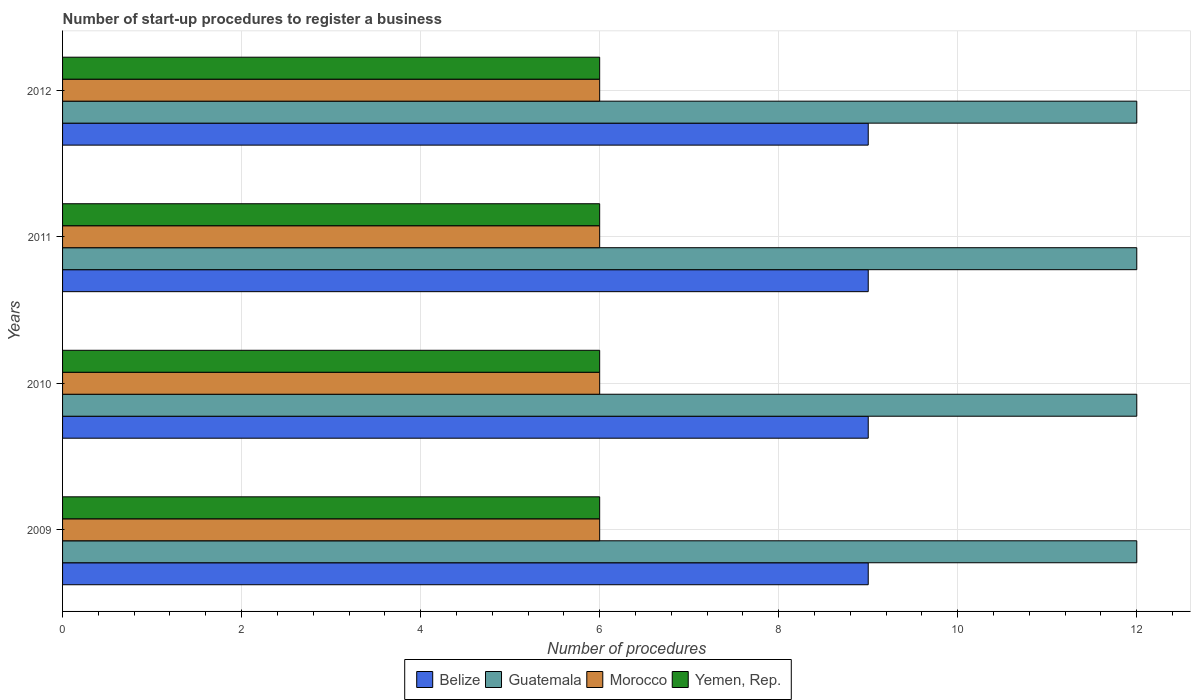How many groups of bars are there?
Offer a very short reply. 4. How many bars are there on the 2nd tick from the top?
Give a very brief answer. 4. How many bars are there on the 3rd tick from the bottom?
Offer a terse response. 4. What is the number of procedures required to register a business in Guatemala in 2011?
Provide a succinct answer. 12. Across all years, what is the maximum number of procedures required to register a business in Guatemala?
Ensure brevity in your answer.  12. In which year was the number of procedures required to register a business in Belize maximum?
Your response must be concise. 2009. What is the total number of procedures required to register a business in Guatemala in the graph?
Your answer should be very brief. 48. What is the difference between the number of procedures required to register a business in Belize in 2010 and that in 2011?
Provide a short and direct response. 0. In the year 2009, what is the difference between the number of procedures required to register a business in Morocco and number of procedures required to register a business in Guatemala?
Offer a terse response. -6. Is the difference between the number of procedures required to register a business in Morocco in 2010 and 2011 greater than the difference between the number of procedures required to register a business in Guatemala in 2010 and 2011?
Your answer should be compact. No. In how many years, is the number of procedures required to register a business in Guatemala greater than the average number of procedures required to register a business in Guatemala taken over all years?
Make the answer very short. 0. Is it the case that in every year, the sum of the number of procedures required to register a business in Morocco and number of procedures required to register a business in Guatemala is greater than the sum of number of procedures required to register a business in Belize and number of procedures required to register a business in Yemen, Rep.?
Make the answer very short. No. What does the 2nd bar from the top in 2012 represents?
Provide a short and direct response. Morocco. What does the 3rd bar from the bottom in 2012 represents?
Provide a short and direct response. Morocco. How many bars are there?
Offer a very short reply. 16. Are all the bars in the graph horizontal?
Ensure brevity in your answer.  Yes. How many years are there in the graph?
Your answer should be compact. 4. What is the difference between two consecutive major ticks on the X-axis?
Your response must be concise. 2. Where does the legend appear in the graph?
Provide a succinct answer. Bottom center. How are the legend labels stacked?
Keep it short and to the point. Horizontal. What is the title of the graph?
Your answer should be very brief. Number of start-up procedures to register a business. What is the label or title of the X-axis?
Your answer should be compact. Number of procedures. What is the Number of procedures in Guatemala in 2009?
Offer a very short reply. 12. What is the Number of procedures in Yemen, Rep. in 2009?
Provide a succinct answer. 6. What is the Number of procedures of Belize in 2010?
Your answer should be compact. 9. What is the Number of procedures in Morocco in 2010?
Provide a succinct answer. 6. What is the Number of procedures in Yemen, Rep. in 2010?
Provide a short and direct response. 6. What is the Number of procedures of Guatemala in 2011?
Make the answer very short. 12. What is the Number of procedures in Morocco in 2012?
Make the answer very short. 6. What is the Number of procedures in Yemen, Rep. in 2012?
Keep it short and to the point. 6. Across all years, what is the maximum Number of procedures in Guatemala?
Give a very brief answer. 12. Across all years, what is the maximum Number of procedures in Yemen, Rep.?
Provide a succinct answer. 6. Across all years, what is the minimum Number of procedures of Belize?
Keep it short and to the point. 9. Across all years, what is the minimum Number of procedures in Morocco?
Your answer should be very brief. 6. What is the difference between the Number of procedures in Morocco in 2009 and that in 2010?
Offer a very short reply. 0. What is the difference between the Number of procedures in Yemen, Rep. in 2009 and that in 2010?
Offer a very short reply. 0. What is the difference between the Number of procedures of Belize in 2009 and that in 2011?
Offer a very short reply. 0. What is the difference between the Number of procedures of Guatemala in 2009 and that in 2011?
Make the answer very short. 0. What is the difference between the Number of procedures of Morocco in 2009 and that in 2011?
Ensure brevity in your answer.  0. What is the difference between the Number of procedures of Yemen, Rep. in 2009 and that in 2011?
Keep it short and to the point. 0. What is the difference between the Number of procedures in Belize in 2009 and that in 2012?
Your answer should be compact. 0. What is the difference between the Number of procedures of Yemen, Rep. in 2009 and that in 2012?
Ensure brevity in your answer.  0. What is the difference between the Number of procedures in Guatemala in 2010 and that in 2011?
Your response must be concise. 0. What is the difference between the Number of procedures in Yemen, Rep. in 2010 and that in 2011?
Your answer should be very brief. 0. What is the difference between the Number of procedures in Belize in 2010 and that in 2012?
Make the answer very short. 0. What is the difference between the Number of procedures of Guatemala in 2010 and that in 2012?
Your response must be concise. 0. What is the difference between the Number of procedures in Yemen, Rep. in 2010 and that in 2012?
Offer a terse response. 0. What is the difference between the Number of procedures of Belize in 2011 and that in 2012?
Offer a very short reply. 0. What is the difference between the Number of procedures in Yemen, Rep. in 2011 and that in 2012?
Your answer should be compact. 0. What is the difference between the Number of procedures of Belize in 2009 and the Number of procedures of Guatemala in 2010?
Give a very brief answer. -3. What is the difference between the Number of procedures of Guatemala in 2009 and the Number of procedures of Morocco in 2010?
Your response must be concise. 6. What is the difference between the Number of procedures in Morocco in 2009 and the Number of procedures in Yemen, Rep. in 2010?
Keep it short and to the point. 0. What is the difference between the Number of procedures of Belize in 2009 and the Number of procedures of Morocco in 2011?
Keep it short and to the point. 3. What is the difference between the Number of procedures of Guatemala in 2009 and the Number of procedures of Yemen, Rep. in 2011?
Provide a succinct answer. 6. What is the difference between the Number of procedures in Morocco in 2009 and the Number of procedures in Yemen, Rep. in 2011?
Offer a terse response. 0. What is the difference between the Number of procedures of Belize in 2009 and the Number of procedures of Guatemala in 2012?
Offer a very short reply. -3. What is the difference between the Number of procedures of Belize in 2009 and the Number of procedures of Morocco in 2012?
Provide a succinct answer. 3. What is the difference between the Number of procedures of Belize in 2009 and the Number of procedures of Yemen, Rep. in 2012?
Keep it short and to the point. 3. What is the difference between the Number of procedures of Guatemala in 2009 and the Number of procedures of Yemen, Rep. in 2012?
Your answer should be very brief. 6. What is the difference between the Number of procedures in Morocco in 2009 and the Number of procedures in Yemen, Rep. in 2012?
Your response must be concise. 0. What is the difference between the Number of procedures of Belize in 2010 and the Number of procedures of Guatemala in 2011?
Offer a very short reply. -3. What is the difference between the Number of procedures of Guatemala in 2010 and the Number of procedures of Morocco in 2011?
Ensure brevity in your answer.  6. What is the difference between the Number of procedures of Belize in 2010 and the Number of procedures of Morocco in 2012?
Offer a very short reply. 3. What is the difference between the Number of procedures in Belize in 2010 and the Number of procedures in Yemen, Rep. in 2012?
Your response must be concise. 3. What is the difference between the Number of procedures in Guatemala in 2010 and the Number of procedures in Morocco in 2012?
Keep it short and to the point. 6. What is the difference between the Number of procedures in Guatemala in 2010 and the Number of procedures in Yemen, Rep. in 2012?
Make the answer very short. 6. What is the difference between the Number of procedures of Morocco in 2010 and the Number of procedures of Yemen, Rep. in 2012?
Your answer should be compact. 0. What is the difference between the Number of procedures in Belize in 2011 and the Number of procedures in Yemen, Rep. in 2012?
Your response must be concise. 3. What is the difference between the Number of procedures in Guatemala in 2011 and the Number of procedures in Yemen, Rep. in 2012?
Give a very brief answer. 6. What is the difference between the Number of procedures of Morocco in 2011 and the Number of procedures of Yemen, Rep. in 2012?
Keep it short and to the point. 0. In the year 2009, what is the difference between the Number of procedures in Belize and Number of procedures in Guatemala?
Your answer should be very brief. -3. In the year 2009, what is the difference between the Number of procedures of Belize and Number of procedures of Morocco?
Provide a succinct answer. 3. In the year 2009, what is the difference between the Number of procedures in Belize and Number of procedures in Yemen, Rep.?
Ensure brevity in your answer.  3. In the year 2009, what is the difference between the Number of procedures of Guatemala and Number of procedures of Yemen, Rep.?
Your answer should be very brief. 6. In the year 2010, what is the difference between the Number of procedures of Belize and Number of procedures of Guatemala?
Offer a very short reply. -3. In the year 2010, what is the difference between the Number of procedures in Belize and Number of procedures in Morocco?
Keep it short and to the point. 3. In the year 2010, what is the difference between the Number of procedures of Belize and Number of procedures of Yemen, Rep.?
Provide a short and direct response. 3. In the year 2010, what is the difference between the Number of procedures of Guatemala and Number of procedures of Yemen, Rep.?
Your response must be concise. 6. In the year 2010, what is the difference between the Number of procedures of Morocco and Number of procedures of Yemen, Rep.?
Provide a short and direct response. 0. In the year 2011, what is the difference between the Number of procedures of Guatemala and Number of procedures of Morocco?
Make the answer very short. 6. In the year 2011, what is the difference between the Number of procedures in Morocco and Number of procedures in Yemen, Rep.?
Make the answer very short. 0. In the year 2012, what is the difference between the Number of procedures in Belize and Number of procedures in Guatemala?
Your answer should be very brief. -3. In the year 2012, what is the difference between the Number of procedures in Belize and Number of procedures in Morocco?
Your answer should be compact. 3. In the year 2012, what is the difference between the Number of procedures in Guatemala and Number of procedures in Morocco?
Provide a short and direct response. 6. In the year 2012, what is the difference between the Number of procedures in Morocco and Number of procedures in Yemen, Rep.?
Give a very brief answer. 0. What is the ratio of the Number of procedures in Belize in 2009 to that in 2010?
Offer a terse response. 1. What is the ratio of the Number of procedures of Guatemala in 2009 to that in 2010?
Your answer should be very brief. 1. What is the ratio of the Number of procedures of Yemen, Rep. in 2009 to that in 2010?
Offer a terse response. 1. What is the ratio of the Number of procedures of Guatemala in 2009 to that in 2012?
Your answer should be very brief. 1. What is the ratio of the Number of procedures of Morocco in 2009 to that in 2012?
Give a very brief answer. 1. What is the ratio of the Number of procedures in Yemen, Rep. in 2009 to that in 2012?
Your answer should be compact. 1. What is the ratio of the Number of procedures in Belize in 2010 to that in 2012?
Offer a very short reply. 1. What is the ratio of the Number of procedures of Guatemala in 2010 to that in 2012?
Ensure brevity in your answer.  1. What is the ratio of the Number of procedures in Morocco in 2010 to that in 2012?
Your response must be concise. 1. What is the ratio of the Number of procedures of Yemen, Rep. in 2010 to that in 2012?
Keep it short and to the point. 1. What is the ratio of the Number of procedures of Guatemala in 2011 to that in 2012?
Keep it short and to the point. 1. What is the ratio of the Number of procedures of Yemen, Rep. in 2011 to that in 2012?
Offer a terse response. 1. What is the difference between the highest and the second highest Number of procedures of Yemen, Rep.?
Give a very brief answer. 0. What is the difference between the highest and the lowest Number of procedures of Morocco?
Offer a terse response. 0. 